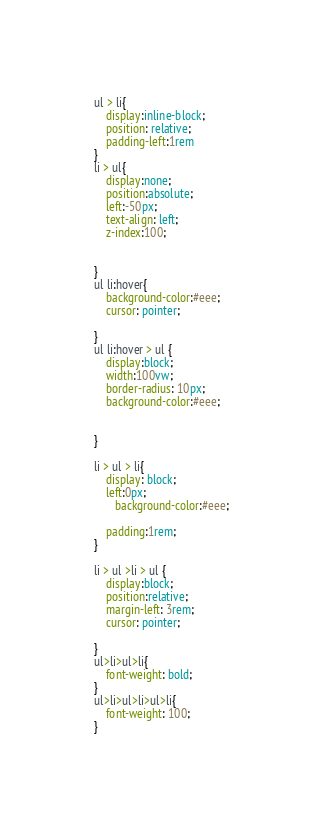<code> <loc_0><loc_0><loc_500><loc_500><_CSS_>ul > li{
    display:inline-block;
    position: relative;
    padding-left:1rem
}
li > ul{
    display:none;
    position:absolute;
    left:-50px;
    text-align: left;
    z-index:100;
    
   
}
ul li:hover{
    background-color:#eee;
    cursor: pointer;

}
ul li:hover > ul {
    display:block;
    width:100vw;  
    border-radius: 10px;
    background-color:#eee;


} 

li > ul > li{
    display: block;
    left:0px;
       background-color:#eee;

    padding:1rem;
}

li > ul >li > ul {
    display:block;  
    position:relative;
    margin-left: 3rem;
    cursor: pointer;

}
ul>li>ul>li{
    font-weight: bold;
}
ul>li>ul>li>ul>li{
    font-weight: 100;
}</code> 